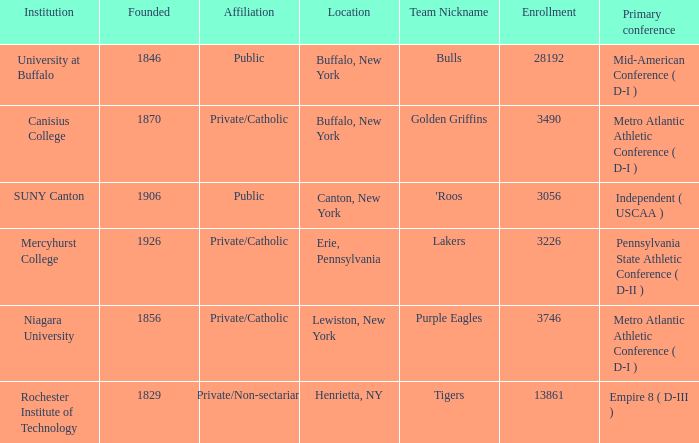What affiliation is Erie, Pennsylvania? Private/Catholic. 